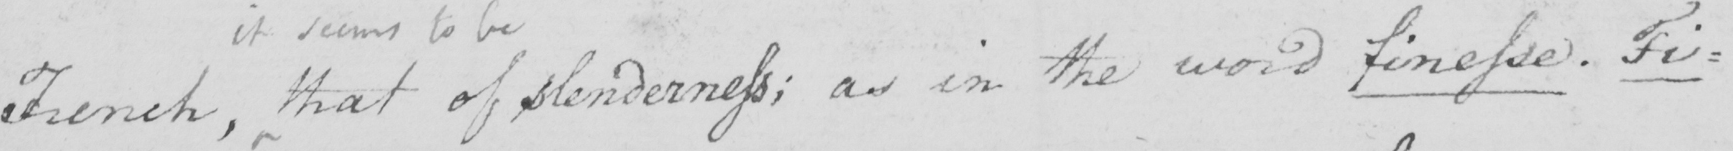Please transcribe the handwritten text in this image. French , that of slenderness ; as in the word finesse . Fi= 